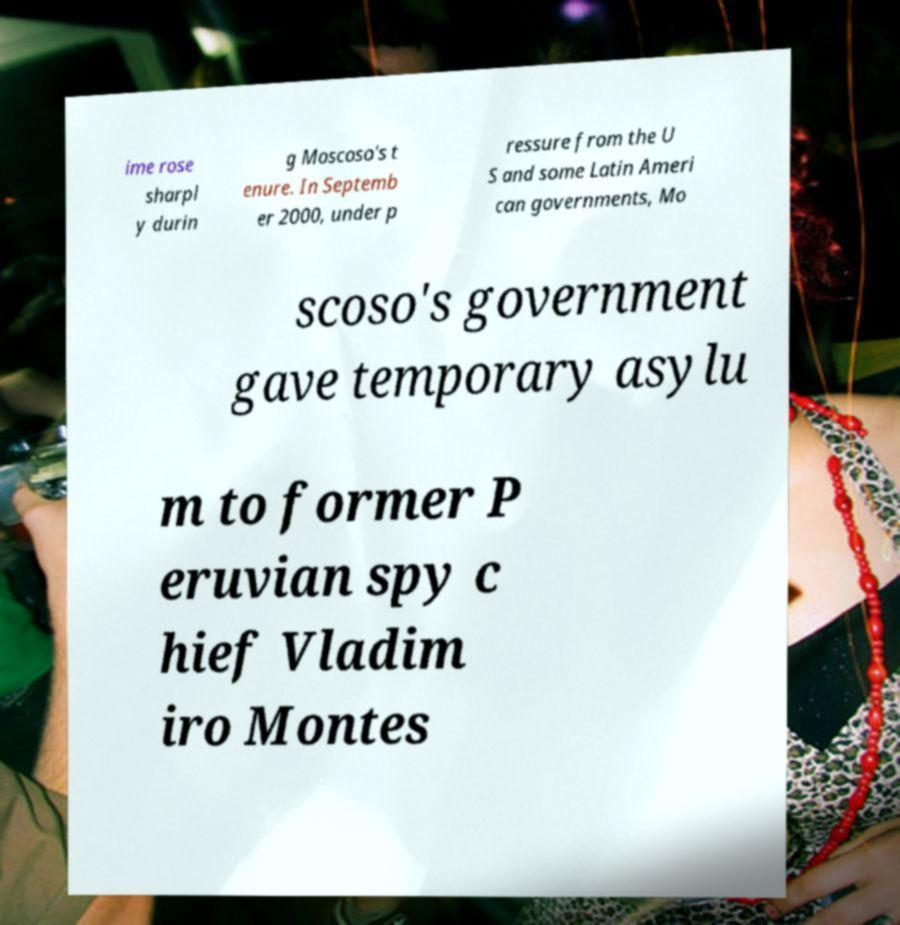For documentation purposes, I need the text within this image transcribed. Could you provide that? ime rose sharpl y durin g Moscoso's t enure. In Septemb er 2000, under p ressure from the U S and some Latin Ameri can governments, Mo scoso's government gave temporary asylu m to former P eruvian spy c hief Vladim iro Montes 